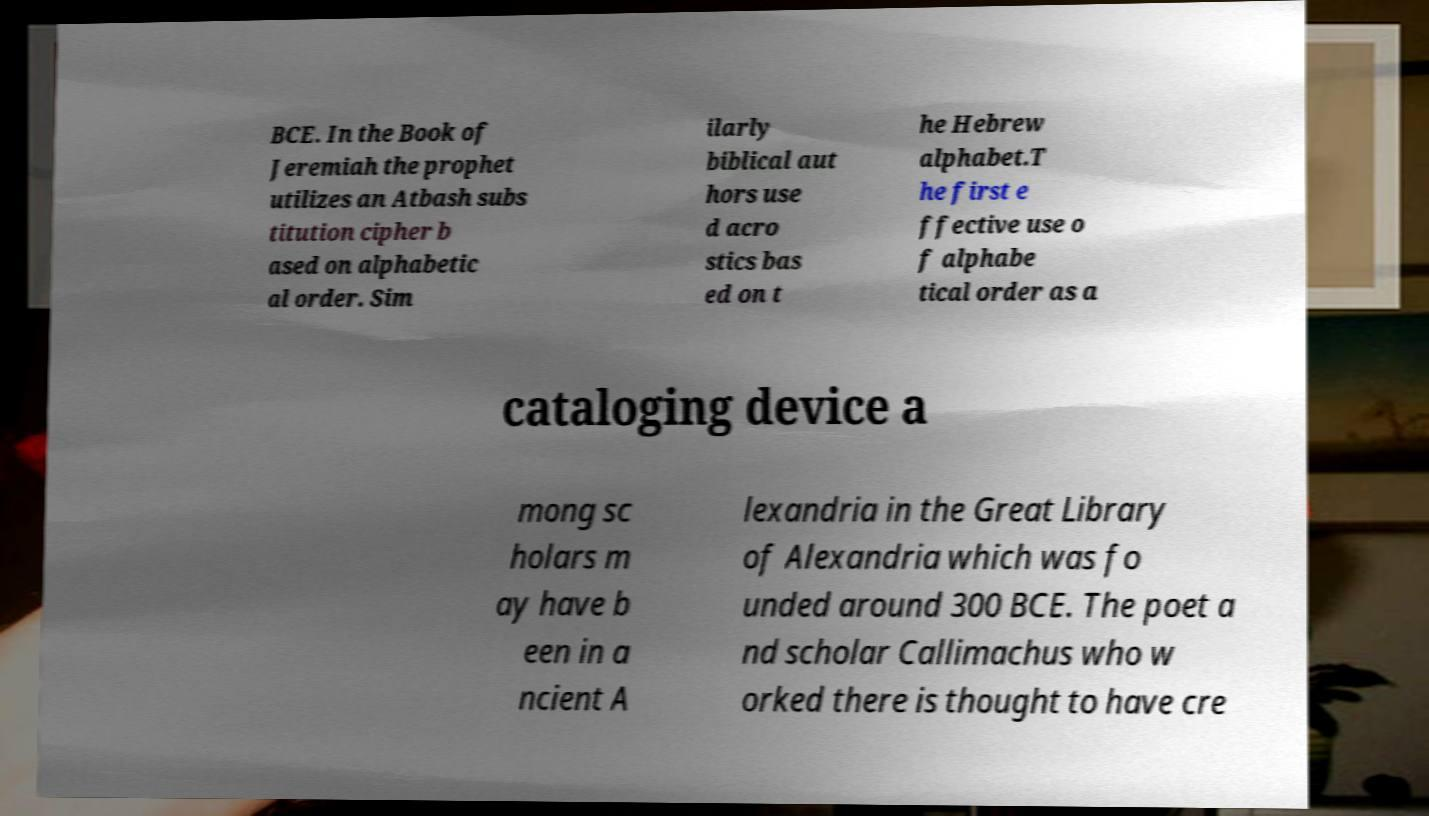Please read and relay the text visible in this image. What does it say? BCE. In the Book of Jeremiah the prophet utilizes an Atbash subs titution cipher b ased on alphabetic al order. Sim ilarly biblical aut hors use d acro stics bas ed on t he Hebrew alphabet.T he first e ffective use o f alphabe tical order as a cataloging device a mong sc holars m ay have b een in a ncient A lexandria in the Great Library of Alexandria which was fo unded around 300 BCE. The poet a nd scholar Callimachus who w orked there is thought to have cre 